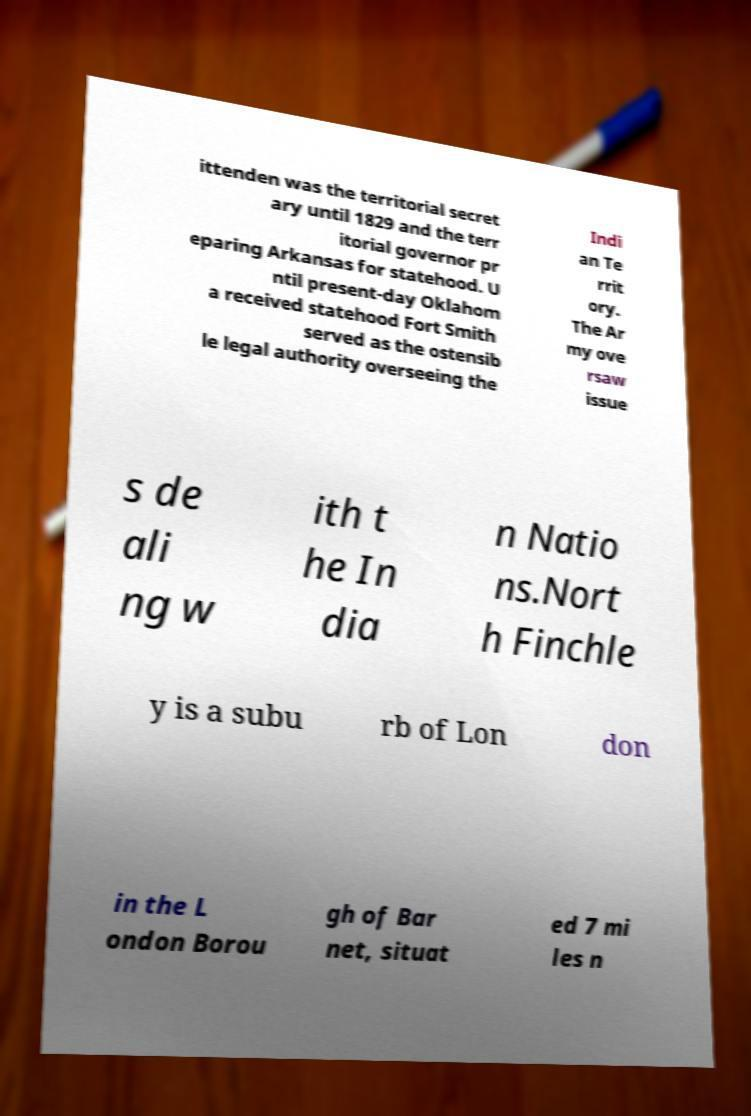Can you accurately transcribe the text from the provided image for me? ittenden was the territorial secret ary until 1829 and the terr itorial governor pr eparing Arkansas for statehood. U ntil present-day Oklahom a received statehood Fort Smith served as the ostensib le legal authority overseeing the Indi an Te rrit ory. The Ar my ove rsaw issue s de ali ng w ith t he In dia n Natio ns.Nort h Finchle y is a subu rb of Lon don in the L ondon Borou gh of Bar net, situat ed 7 mi les n 